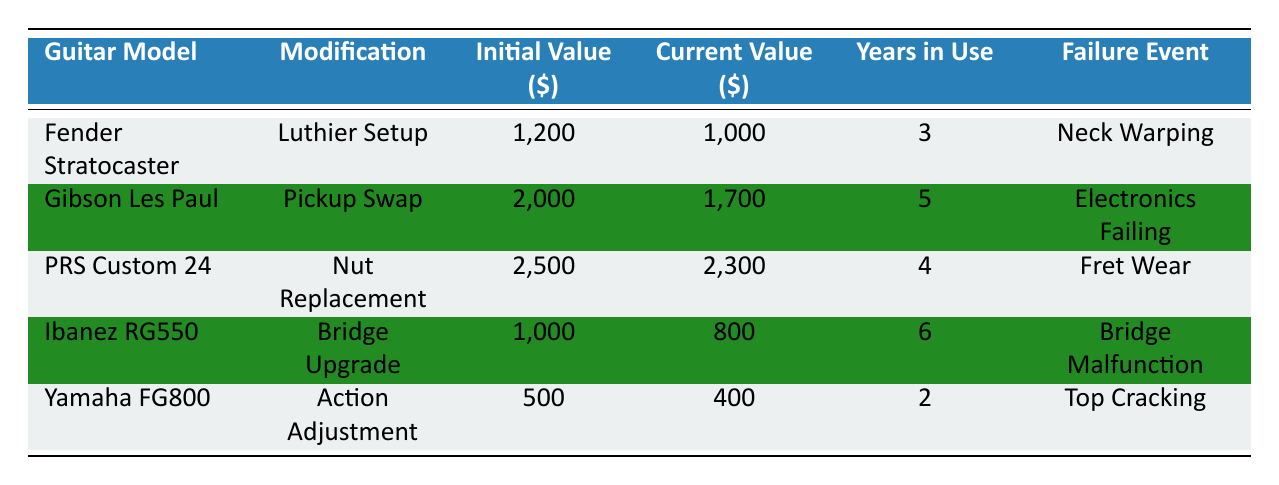What is the Initial Value of the PRS Custom 24? The table lists the Initial Value for each guitar model. For the PRS Custom 24, the value is explicitly shown as 2500.
Answer: 2500 Which guitar has the longest survival time? By comparing the Survival Time Months column, the maximum value is 72 months for the Ibanez RG550, which indicates it has the longest survival time among the listed guitars.
Answer: Ibanez RG550 What is the Current Value of the Fender Stratocaster? The Current Value for the Fender Stratocaster is provided directly in the table as 1000, which can be found in the corresponding row.
Answer: 1000 Is the Yamaha FG800's failure event "Top Cracking"? Looking at the Failure Event column for the Yamaha FG800, indeed, it states that the failure event is "Top Cracking".
Answer: Yes What is the total Initial Value of all the guitars? To find the total Initial Value, we sum up the values: 1200 + 2000 + 2500 + 1000 + 500 = 7200. This calculation compiles the Initial Values from each row in the Initial Value column.
Answer: 7200 How many guitars had a Current Value higher than 1500? Reviewing the Current Value column, three guitars have a value higher than 1500: the Gibson Les Paul (1700), PRS Custom 24 (2300), and Fender Stratocaster (1000). Therefore, two out of five guitars have a Current Value over 1500.
Answer: 2 What is the average Current Value of the listed guitars? First, we sum the Current Values: 1000 + 1700 + 2300 + 800 + 400 = 6200. Then, divide this sum by the number of guitars (5) to get the average: 6200 / 5 = 1240.
Answer: 1240 Does any guitar have a modification type called "Bridge Upgrade"? By checking the Modification Type column, the Ibanez RG550 clearly indicates it underwent a "Bridge Upgrade," confirming this modification exists among the listed guitars.
Answer: Yes Which guitar has experienced the failure event of "Electronics Failing"? The table shows the Gibson Les Paul as having the failure event "Electronics Failing," which is evident from the Failure Event column.
Answer: Gibson Les Paul 